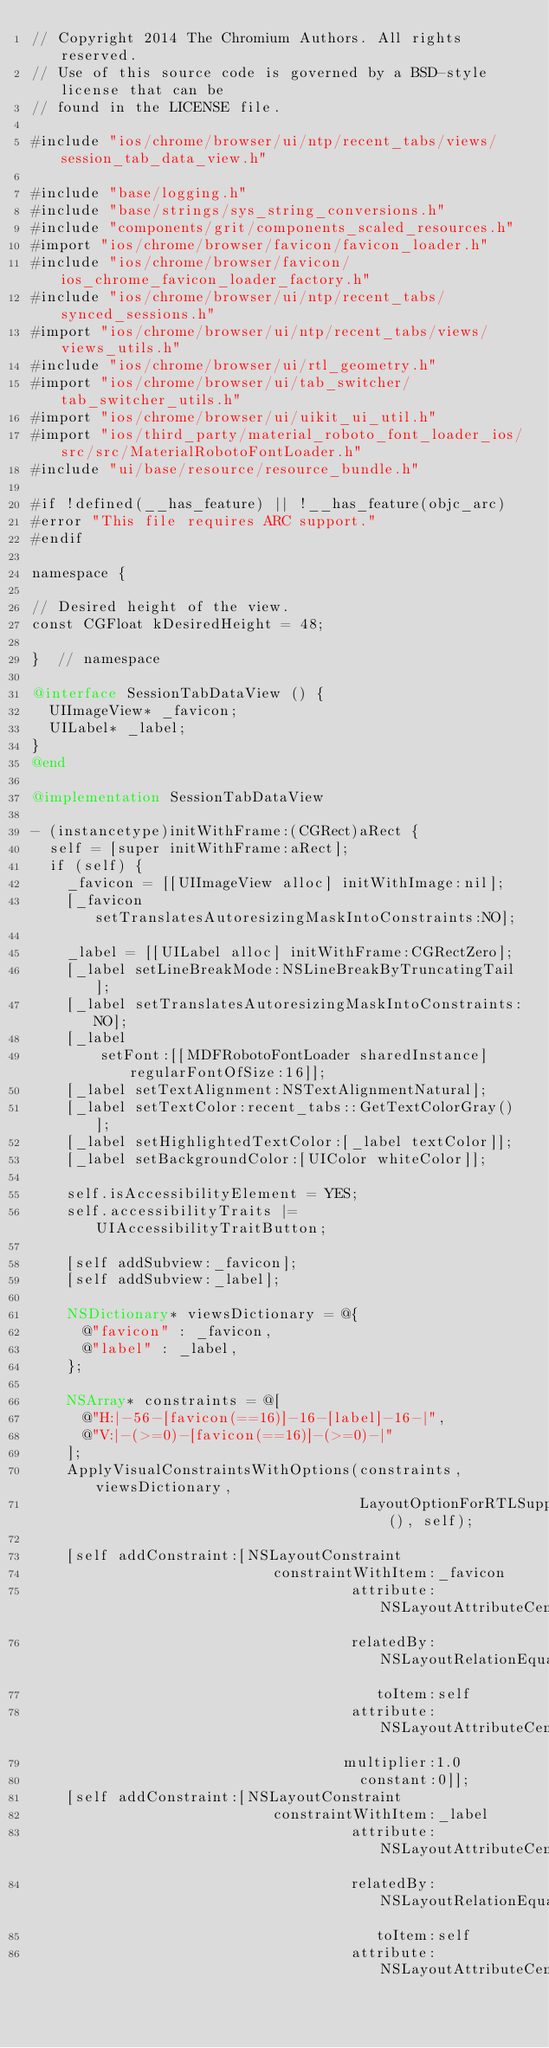<code> <loc_0><loc_0><loc_500><loc_500><_ObjectiveC_>// Copyright 2014 The Chromium Authors. All rights reserved.
// Use of this source code is governed by a BSD-style license that can be
// found in the LICENSE file.

#include "ios/chrome/browser/ui/ntp/recent_tabs/views/session_tab_data_view.h"

#include "base/logging.h"
#include "base/strings/sys_string_conversions.h"
#include "components/grit/components_scaled_resources.h"
#import "ios/chrome/browser/favicon/favicon_loader.h"
#include "ios/chrome/browser/favicon/ios_chrome_favicon_loader_factory.h"
#include "ios/chrome/browser/ui/ntp/recent_tabs/synced_sessions.h"
#import "ios/chrome/browser/ui/ntp/recent_tabs/views/views_utils.h"
#include "ios/chrome/browser/ui/rtl_geometry.h"
#import "ios/chrome/browser/ui/tab_switcher/tab_switcher_utils.h"
#import "ios/chrome/browser/ui/uikit_ui_util.h"
#import "ios/third_party/material_roboto_font_loader_ios/src/src/MaterialRobotoFontLoader.h"
#include "ui/base/resource/resource_bundle.h"

#if !defined(__has_feature) || !__has_feature(objc_arc)
#error "This file requires ARC support."
#endif

namespace {

// Desired height of the view.
const CGFloat kDesiredHeight = 48;

}  // namespace

@interface SessionTabDataView () {
  UIImageView* _favicon;
  UILabel* _label;
}
@end

@implementation SessionTabDataView

- (instancetype)initWithFrame:(CGRect)aRect {
  self = [super initWithFrame:aRect];
  if (self) {
    _favicon = [[UIImageView alloc] initWithImage:nil];
    [_favicon setTranslatesAutoresizingMaskIntoConstraints:NO];

    _label = [[UILabel alloc] initWithFrame:CGRectZero];
    [_label setLineBreakMode:NSLineBreakByTruncatingTail];
    [_label setTranslatesAutoresizingMaskIntoConstraints:NO];
    [_label
        setFont:[[MDFRobotoFontLoader sharedInstance] regularFontOfSize:16]];
    [_label setTextAlignment:NSTextAlignmentNatural];
    [_label setTextColor:recent_tabs::GetTextColorGray()];
    [_label setHighlightedTextColor:[_label textColor]];
    [_label setBackgroundColor:[UIColor whiteColor]];

    self.isAccessibilityElement = YES;
    self.accessibilityTraits |= UIAccessibilityTraitButton;

    [self addSubview:_favicon];
    [self addSubview:_label];

    NSDictionary* viewsDictionary = @{
      @"favicon" : _favicon,
      @"label" : _label,
    };

    NSArray* constraints = @[
      @"H:|-56-[favicon(==16)]-16-[label]-16-|",
      @"V:|-(>=0)-[favicon(==16)]-(>=0)-|"
    ];
    ApplyVisualConstraintsWithOptions(constraints, viewsDictionary,
                                      LayoutOptionForRTLSupport(), self);

    [self addConstraint:[NSLayoutConstraint
                            constraintWithItem:_favicon
                                     attribute:NSLayoutAttributeCenterY
                                     relatedBy:NSLayoutRelationEqual
                                        toItem:self
                                     attribute:NSLayoutAttributeCenterY
                                    multiplier:1.0
                                      constant:0]];
    [self addConstraint:[NSLayoutConstraint
                            constraintWithItem:_label
                                     attribute:NSLayoutAttributeCenterY
                                     relatedBy:NSLayoutRelationEqual
                                        toItem:self
                                     attribute:NSLayoutAttributeCenterY</code> 